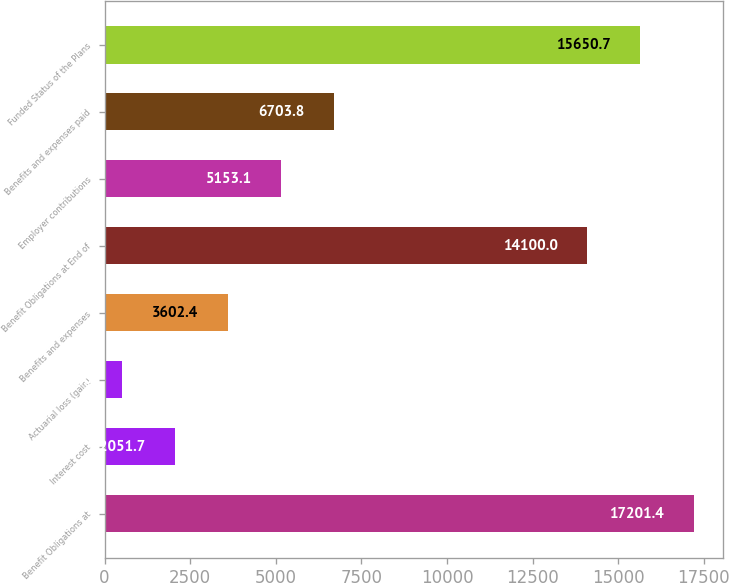Convert chart to OTSL. <chart><loc_0><loc_0><loc_500><loc_500><bar_chart><fcel>Benefit Obligations at<fcel>Interest cost<fcel>Actuarial loss (gain)<fcel>Benefits and expenses<fcel>Benefit Obligations at End of<fcel>Employer contributions<fcel>Benefits and expenses paid<fcel>Funded Status of the Plans<nl><fcel>17201.4<fcel>2051.7<fcel>501<fcel>3602.4<fcel>14100<fcel>5153.1<fcel>6703.8<fcel>15650.7<nl></chart> 